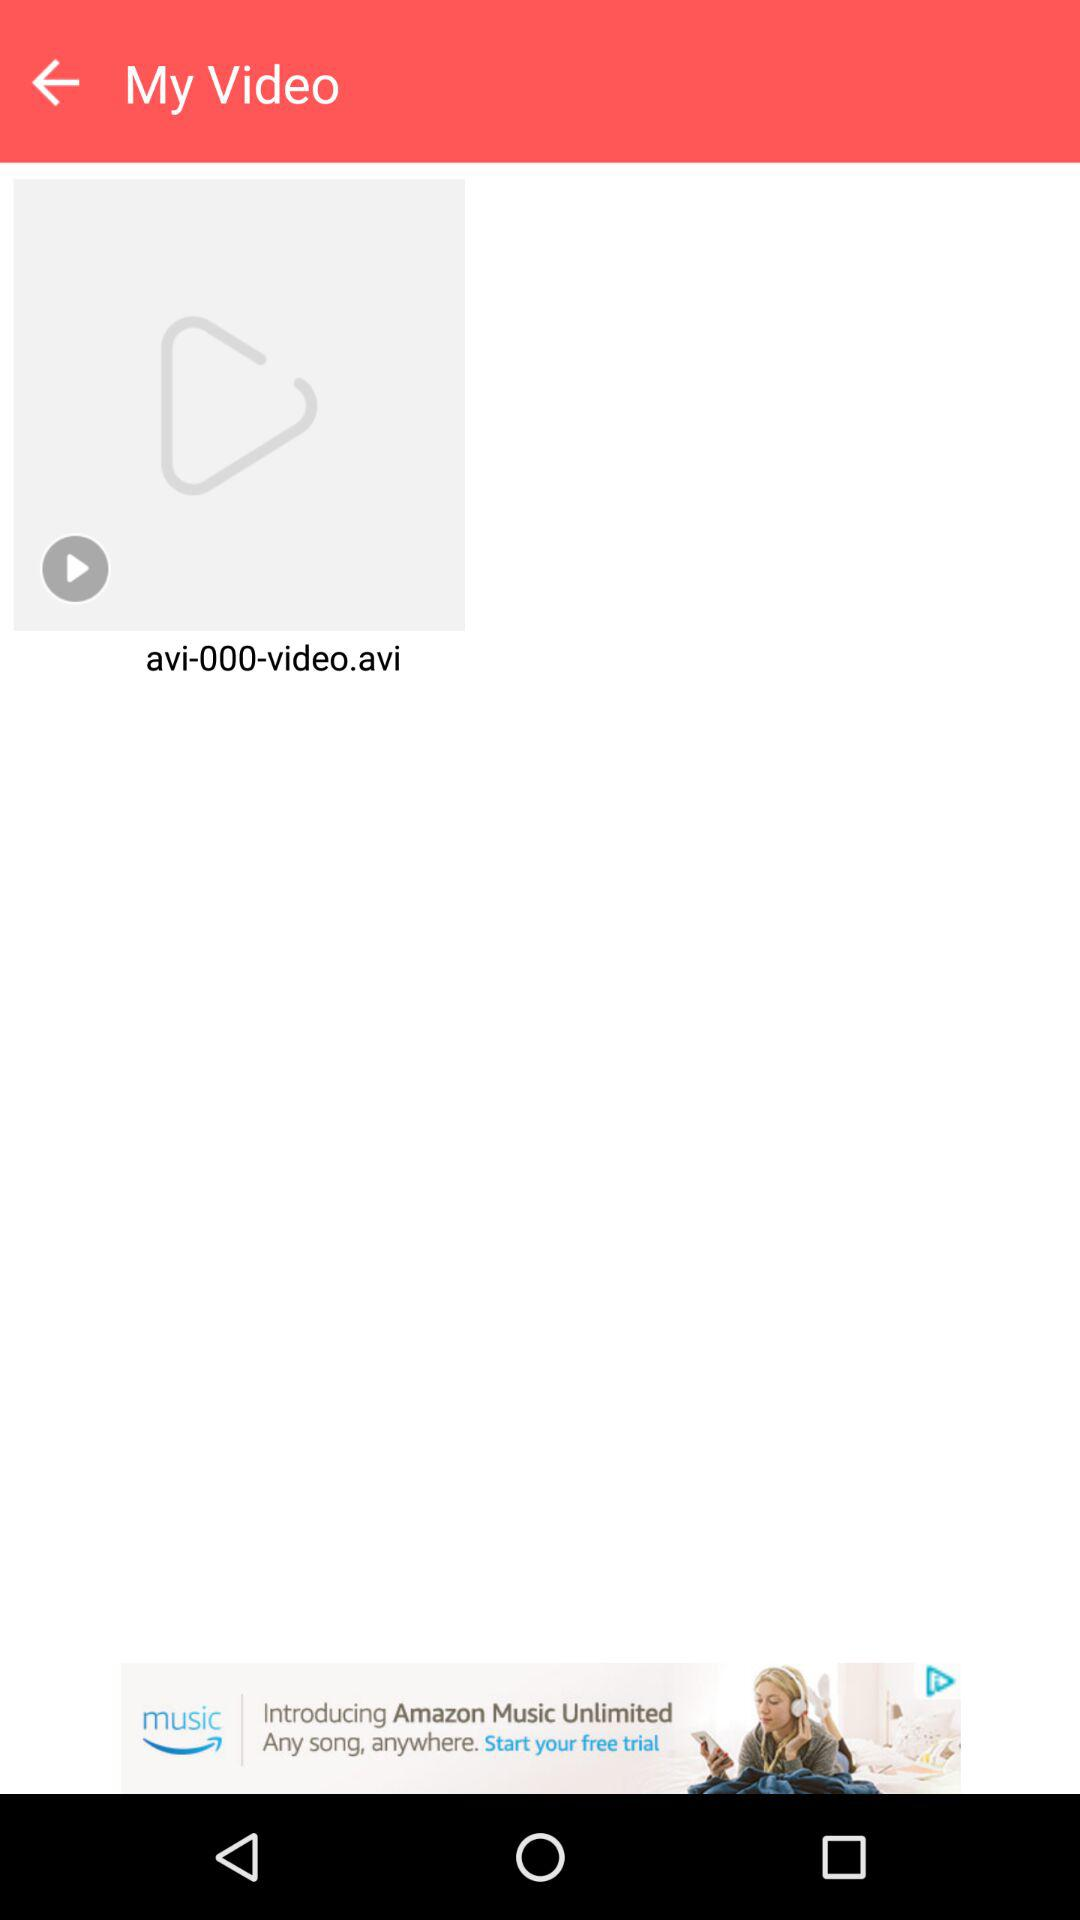What is the name of the video? The name of the video is "avi-000-video.avi". 